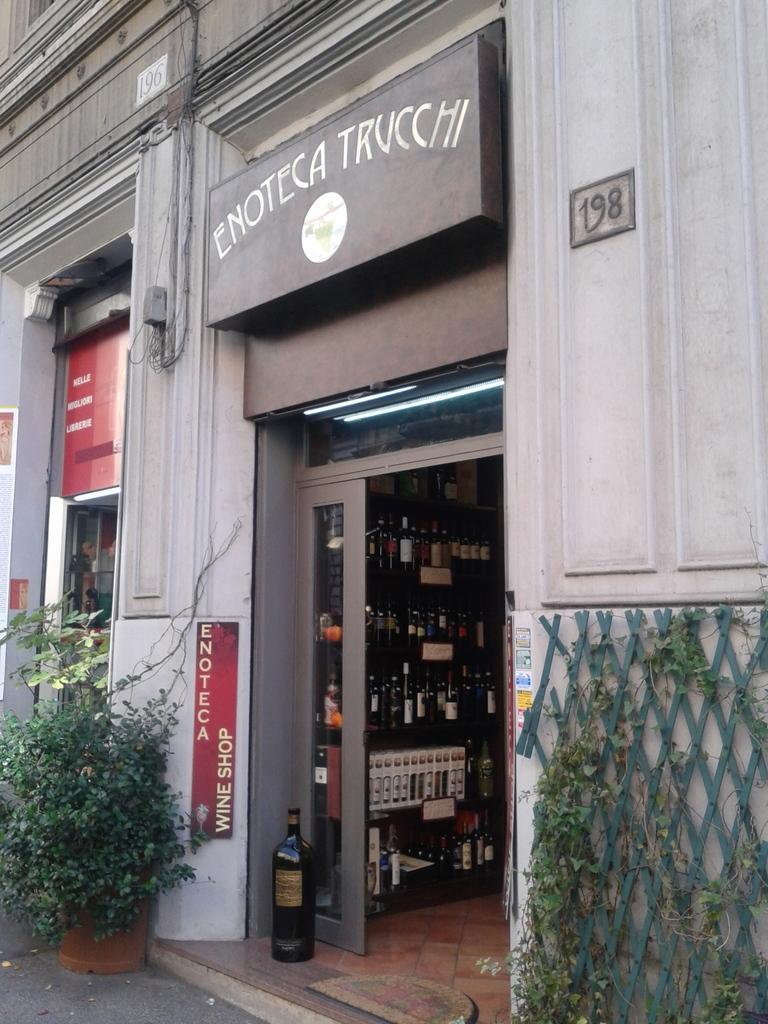How would you summarize this image in a sentence or two? In the center of the image there is a building. At the bottom we can see a shelf and there are bottles placed in the shelf. There is a jar. On the left we can see a plant. On the right there is a fence. 